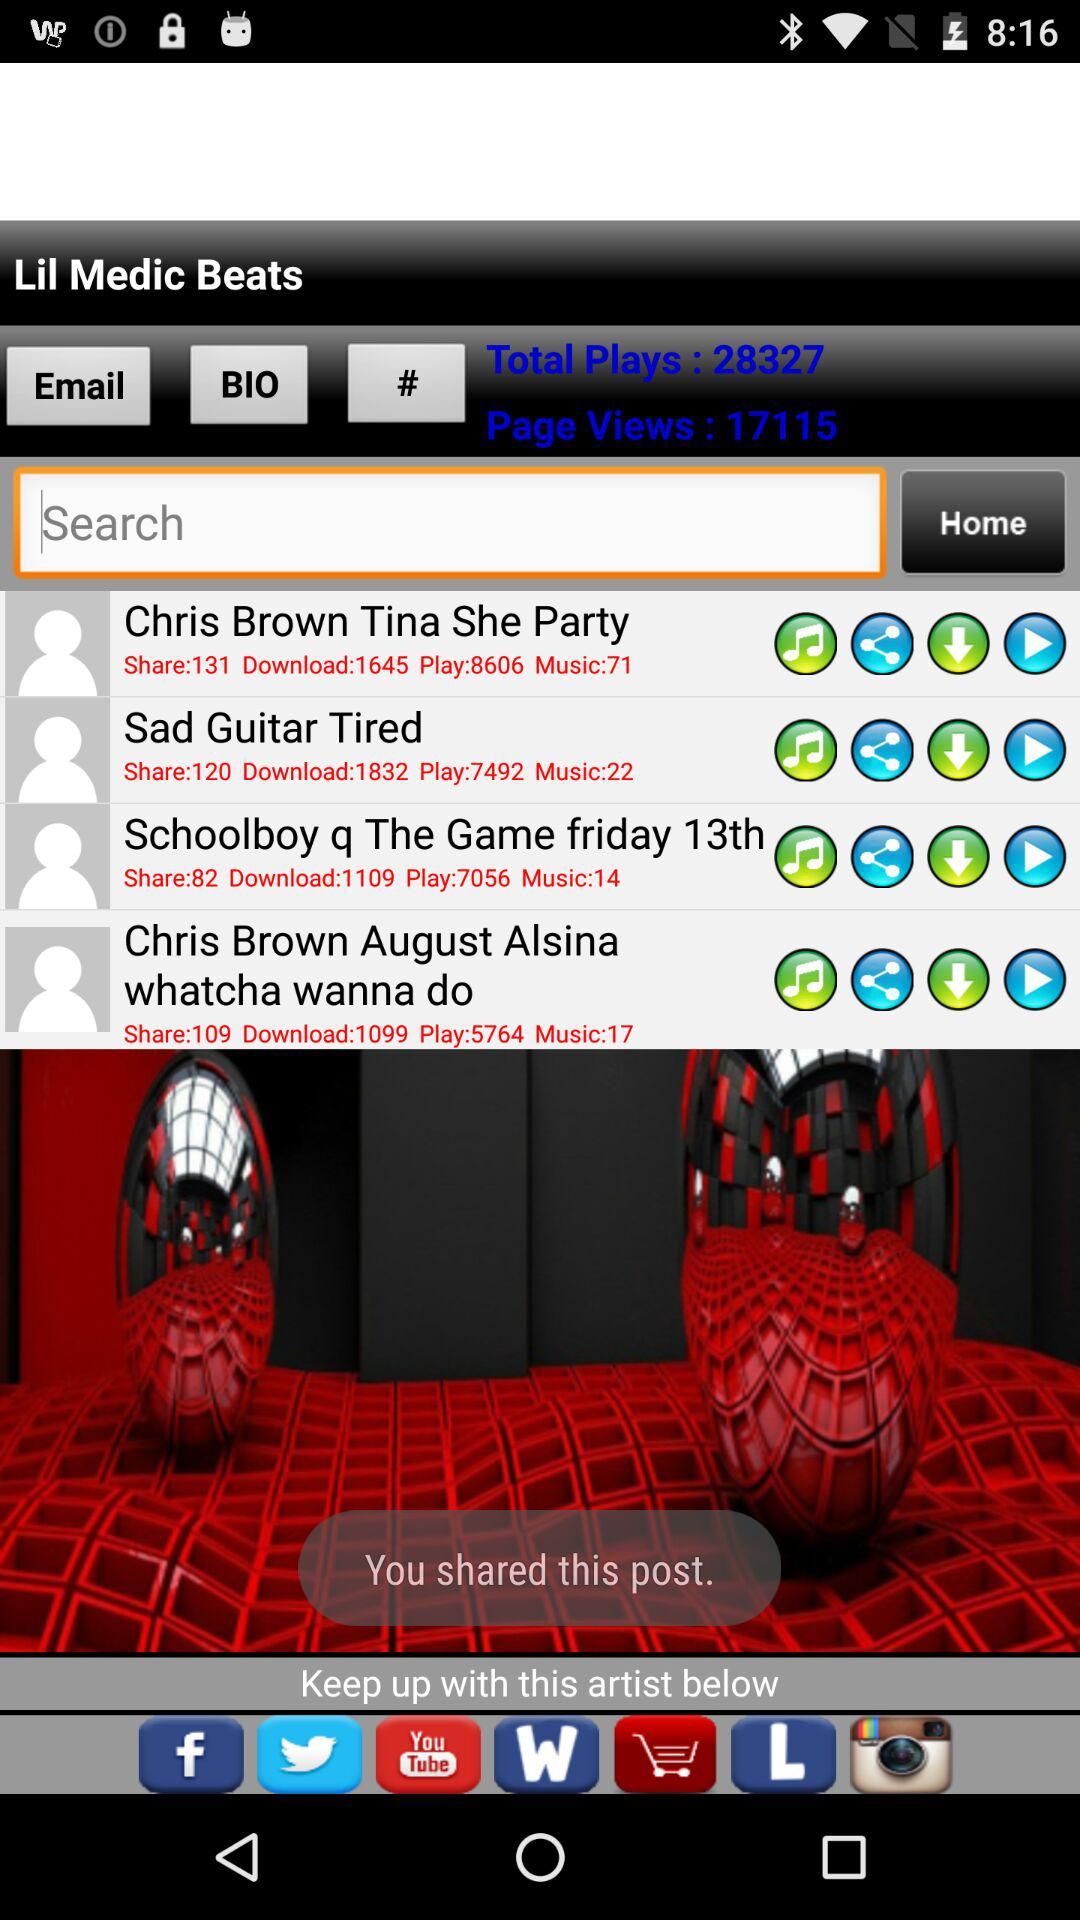What's the total number of plays? The total number of plays is 28327. 